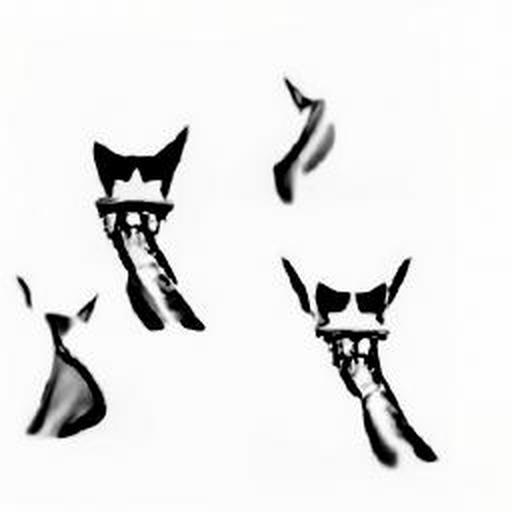Can you describe the subjects and their positioning in this artwork? The image features abstract representations that resemble animal figures, possibly felines, arranged in a dynamic, asymmetrical composition. The figures seem to float independently of one another, with varying degrees of blurriness and orientation, creating an ethereal and slightly enigmatic visual narrative. 